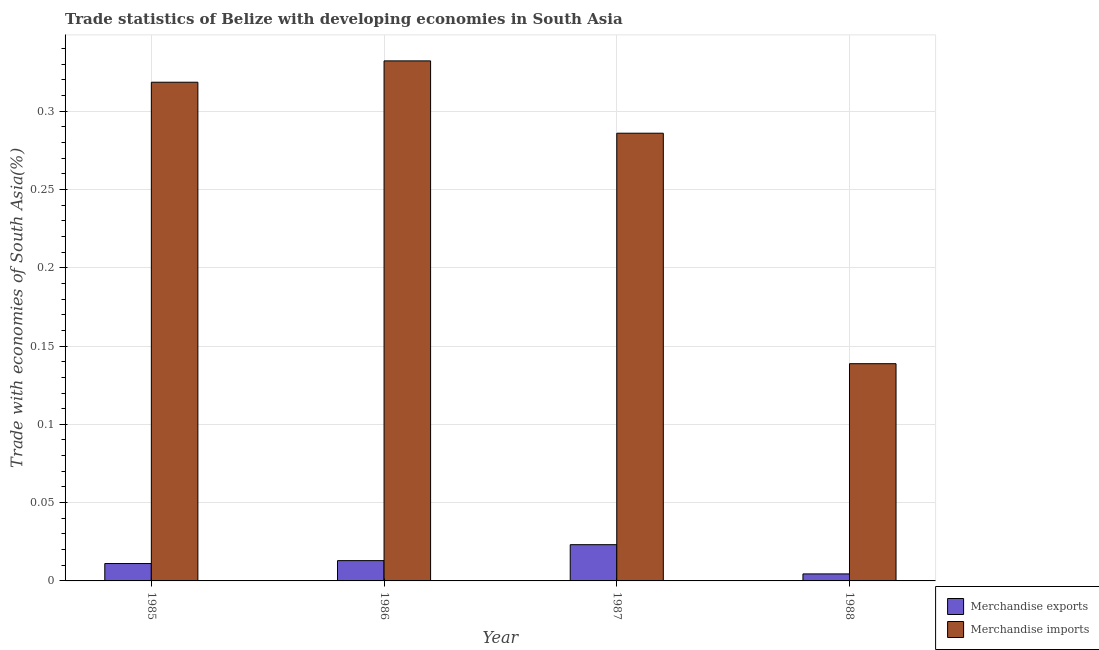How many different coloured bars are there?
Your response must be concise. 2. How many bars are there on the 3rd tick from the left?
Keep it short and to the point. 2. How many bars are there on the 4th tick from the right?
Offer a very short reply. 2. What is the label of the 4th group of bars from the left?
Keep it short and to the point. 1988. In how many cases, is the number of bars for a given year not equal to the number of legend labels?
Make the answer very short. 0. What is the merchandise imports in 1987?
Provide a short and direct response. 0.29. Across all years, what is the maximum merchandise exports?
Provide a succinct answer. 0.02. Across all years, what is the minimum merchandise exports?
Your response must be concise. 0. What is the total merchandise exports in the graph?
Your answer should be compact. 0.05. What is the difference between the merchandise exports in 1985 and that in 1988?
Ensure brevity in your answer.  0.01. What is the difference between the merchandise exports in 1986 and the merchandise imports in 1987?
Offer a terse response. -0.01. What is the average merchandise exports per year?
Provide a succinct answer. 0.01. In the year 1986, what is the difference between the merchandise exports and merchandise imports?
Give a very brief answer. 0. What is the ratio of the merchandise imports in 1986 to that in 1988?
Give a very brief answer. 2.39. What is the difference between the highest and the second highest merchandise imports?
Offer a terse response. 0.01. What is the difference between the highest and the lowest merchandise imports?
Offer a very short reply. 0.19. Is the sum of the merchandise imports in 1986 and 1988 greater than the maximum merchandise exports across all years?
Offer a very short reply. Yes. What does the 1st bar from the right in 1986 represents?
Make the answer very short. Merchandise imports. How many years are there in the graph?
Offer a terse response. 4. Does the graph contain any zero values?
Offer a terse response. No. Where does the legend appear in the graph?
Your response must be concise. Bottom right. What is the title of the graph?
Provide a short and direct response. Trade statistics of Belize with developing economies in South Asia. Does "International Visitors" appear as one of the legend labels in the graph?
Provide a short and direct response. No. What is the label or title of the Y-axis?
Keep it short and to the point. Trade with economies of South Asia(%). What is the Trade with economies of South Asia(%) of Merchandise exports in 1985?
Give a very brief answer. 0.01. What is the Trade with economies of South Asia(%) of Merchandise imports in 1985?
Provide a short and direct response. 0.32. What is the Trade with economies of South Asia(%) in Merchandise exports in 1986?
Ensure brevity in your answer.  0.01. What is the Trade with economies of South Asia(%) in Merchandise imports in 1986?
Provide a succinct answer. 0.33. What is the Trade with economies of South Asia(%) of Merchandise exports in 1987?
Your response must be concise. 0.02. What is the Trade with economies of South Asia(%) in Merchandise imports in 1987?
Offer a terse response. 0.29. What is the Trade with economies of South Asia(%) in Merchandise exports in 1988?
Your answer should be compact. 0. What is the Trade with economies of South Asia(%) of Merchandise imports in 1988?
Provide a short and direct response. 0.14. Across all years, what is the maximum Trade with economies of South Asia(%) in Merchandise exports?
Give a very brief answer. 0.02. Across all years, what is the maximum Trade with economies of South Asia(%) of Merchandise imports?
Your answer should be compact. 0.33. Across all years, what is the minimum Trade with economies of South Asia(%) of Merchandise exports?
Provide a short and direct response. 0. Across all years, what is the minimum Trade with economies of South Asia(%) in Merchandise imports?
Provide a succinct answer. 0.14. What is the total Trade with economies of South Asia(%) in Merchandise exports in the graph?
Offer a very short reply. 0.05. What is the total Trade with economies of South Asia(%) in Merchandise imports in the graph?
Ensure brevity in your answer.  1.08. What is the difference between the Trade with economies of South Asia(%) in Merchandise exports in 1985 and that in 1986?
Make the answer very short. -0. What is the difference between the Trade with economies of South Asia(%) of Merchandise imports in 1985 and that in 1986?
Your answer should be very brief. -0.01. What is the difference between the Trade with economies of South Asia(%) in Merchandise exports in 1985 and that in 1987?
Make the answer very short. -0.01. What is the difference between the Trade with economies of South Asia(%) of Merchandise imports in 1985 and that in 1987?
Give a very brief answer. 0.03. What is the difference between the Trade with economies of South Asia(%) in Merchandise exports in 1985 and that in 1988?
Your answer should be compact. 0.01. What is the difference between the Trade with economies of South Asia(%) of Merchandise imports in 1985 and that in 1988?
Keep it short and to the point. 0.18. What is the difference between the Trade with economies of South Asia(%) in Merchandise exports in 1986 and that in 1987?
Keep it short and to the point. -0.01. What is the difference between the Trade with economies of South Asia(%) in Merchandise imports in 1986 and that in 1987?
Your answer should be compact. 0.05. What is the difference between the Trade with economies of South Asia(%) of Merchandise exports in 1986 and that in 1988?
Provide a succinct answer. 0.01. What is the difference between the Trade with economies of South Asia(%) in Merchandise imports in 1986 and that in 1988?
Keep it short and to the point. 0.19. What is the difference between the Trade with economies of South Asia(%) in Merchandise exports in 1987 and that in 1988?
Your response must be concise. 0.02. What is the difference between the Trade with economies of South Asia(%) of Merchandise imports in 1987 and that in 1988?
Provide a short and direct response. 0.15. What is the difference between the Trade with economies of South Asia(%) in Merchandise exports in 1985 and the Trade with economies of South Asia(%) in Merchandise imports in 1986?
Offer a terse response. -0.32. What is the difference between the Trade with economies of South Asia(%) in Merchandise exports in 1985 and the Trade with economies of South Asia(%) in Merchandise imports in 1987?
Offer a very short reply. -0.27. What is the difference between the Trade with economies of South Asia(%) of Merchandise exports in 1985 and the Trade with economies of South Asia(%) of Merchandise imports in 1988?
Ensure brevity in your answer.  -0.13. What is the difference between the Trade with economies of South Asia(%) in Merchandise exports in 1986 and the Trade with economies of South Asia(%) in Merchandise imports in 1987?
Offer a very short reply. -0.27. What is the difference between the Trade with economies of South Asia(%) in Merchandise exports in 1986 and the Trade with economies of South Asia(%) in Merchandise imports in 1988?
Your answer should be very brief. -0.13. What is the difference between the Trade with economies of South Asia(%) of Merchandise exports in 1987 and the Trade with economies of South Asia(%) of Merchandise imports in 1988?
Ensure brevity in your answer.  -0.12. What is the average Trade with economies of South Asia(%) of Merchandise exports per year?
Ensure brevity in your answer.  0.01. What is the average Trade with economies of South Asia(%) in Merchandise imports per year?
Provide a succinct answer. 0.27. In the year 1985, what is the difference between the Trade with economies of South Asia(%) of Merchandise exports and Trade with economies of South Asia(%) of Merchandise imports?
Make the answer very short. -0.31. In the year 1986, what is the difference between the Trade with economies of South Asia(%) in Merchandise exports and Trade with economies of South Asia(%) in Merchandise imports?
Provide a short and direct response. -0.32. In the year 1987, what is the difference between the Trade with economies of South Asia(%) of Merchandise exports and Trade with economies of South Asia(%) of Merchandise imports?
Your answer should be compact. -0.26. In the year 1988, what is the difference between the Trade with economies of South Asia(%) in Merchandise exports and Trade with economies of South Asia(%) in Merchandise imports?
Your answer should be compact. -0.13. What is the ratio of the Trade with economies of South Asia(%) of Merchandise exports in 1985 to that in 1986?
Offer a very short reply. 0.86. What is the ratio of the Trade with economies of South Asia(%) of Merchandise imports in 1985 to that in 1986?
Ensure brevity in your answer.  0.96. What is the ratio of the Trade with economies of South Asia(%) in Merchandise exports in 1985 to that in 1987?
Keep it short and to the point. 0.48. What is the ratio of the Trade with economies of South Asia(%) of Merchandise imports in 1985 to that in 1987?
Make the answer very short. 1.11. What is the ratio of the Trade with economies of South Asia(%) in Merchandise exports in 1985 to that in 1988?
Offer a terse response. 2.48. What is the ratio of the Trade with economies of South Asia(%) in Merchandise imports in 1985 to that in 1988?
Your answer should be very brief. 2.3. What is the ratio of the Trade with economies of South Asia(%) of Merchandise exports in 1986 to that in 1987?
Your answer should be compact. 0.56. What is the ratio of the Trade with economies of South Asia(%) in Merchandise imports in 1986 to that in 1987?
Offer a terse response. 1.16. What is the ratio of the Trade with economies of South Asia(%) in Merchandise exports in 1986 to that in 1988?
Provide a short and direct response. 2.9. What is the ratio of the Trade with economies of South Asia(%) of Merchandise imports in 1986 to that in 1988?
Provide a succinct answer. 2.39. What is the ratio of the Trade with economies of South Asia(%) of Merchandise exports in 1987 to that in 1988?
Make the answer very short. 5.18. What is the ratio of the Trade with economies of South Asia(%) in Merchandise imports in 1987 to that in 1988?
Ensure brevity in your answer.  2.06. What is the difference between the highest and the second highest Trade with economies of South Asia(%) of Merchandise exports?
Ensure brevity in your answer.  0.01. What is the difference between the highest and the second highest Trade with economies of South Asia(%) of Merchandise imports?
Provide a short and direct response. 0.01. What is the difference between the highest and the lowest Trade with economies of South Asia(%) of Merchandise exports?
Offer a terse response. 0.02. What is the difference between the highest and the lowest Trade with economies of South Asia(%) of Merchandise imports?
Your answer should be compact. 0.19. 